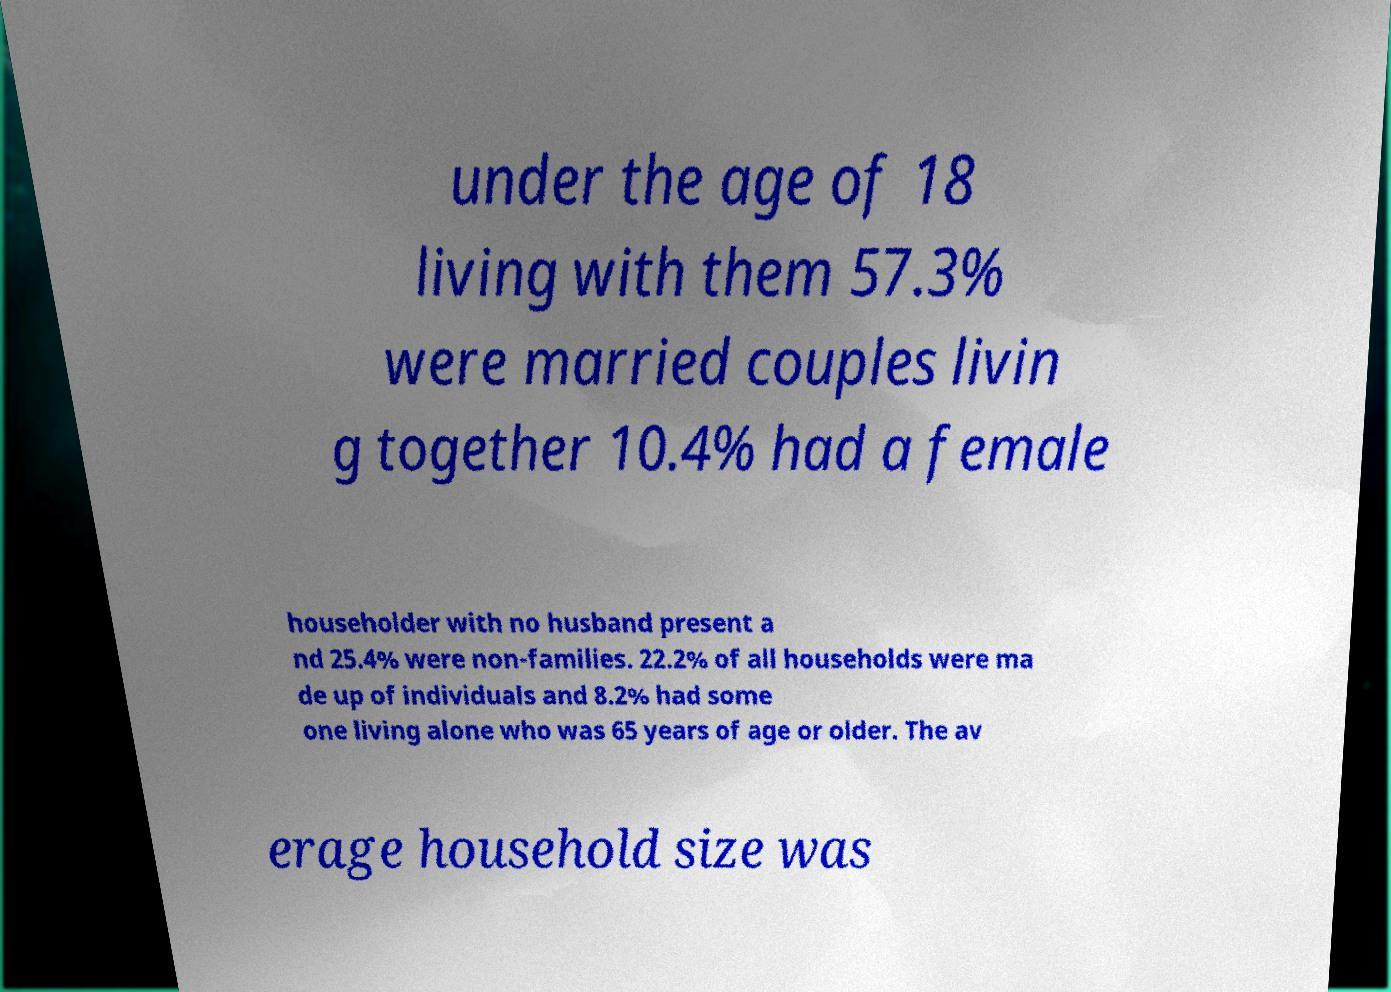Could you assist in decoding the text presented in this image and type it out clearly? under the age of 18 living with them 57.3% were married couples livin g together 10.4% had a female householder with no husband present a nd 25.4% were non-families. 22.2% of all households were ma de up of individuals and 8.2% had some one living alone who was 65 years of age or older. The av erage household size was 